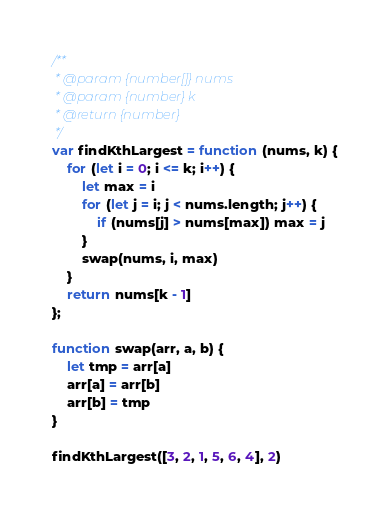Convert code to text. <code><loc_0><loc_0><loc_500><loc_500><_JavaScript_>/**
 * @param {number[]} nums
 * @param {number} k
 * @return {number}
 */
var findKthLargest = function (nums, k) {
    for (let i = 0; i <= k; i++) {
        let max = i
        for (let j = i; j < nums.length; j++) {
            if (nums[j] > nums[max]) max = j
        }
        swap(nums, i, max)
    }
    return nums[k - 1]
};

function swap(arr, a, b) {
    let tmp = arr[a]
    arr[a] = arr[b]
    arr[b] = tmp
}

findKthLargest([3, 2, 1, 5, 6, 4], 2)</code> 